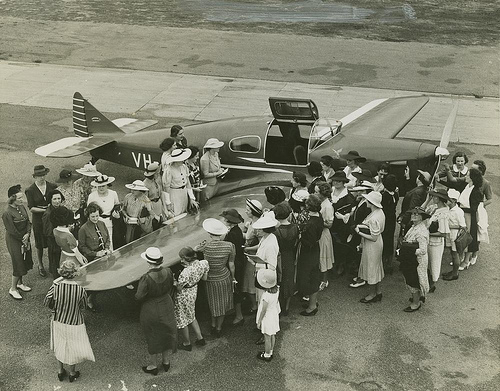What style of clothing are the individuals wearing? The individuals are wearing attire typical of the early 20th century. For the women, this includes hats with wide brims, belted dresses, and gloves. The men are in suits, some wearing hats, which is indicative of the formal fashion of that time period. 